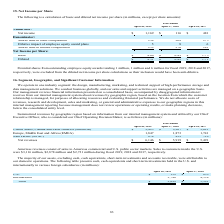According to Netapp's financial document, What was the sales to customers inside the U.S. in 2017? According to the financial document, $2,721 million. The relevant text states: "e the U.S. were $3,116 million, $2,878 million and $2,721 million during fiscal 2019, 2018 and 2017, respectively...." Also, Which years does the table provide information for Summarized revenues by geographic region? The document contains multiple relevant values: 2019, 2018, 2017. From the document: "April 26, 2019 April 27, 2018 April 28, 2017 April 26, 2019 April 27, 2018 April 28, 2017 April 26, 2019 April 27, 2018 April 28, 2017..." Also, Which industry segment does the company operate in? the design, manufacturing, marketing, and technical support of high-performance storage and data management solutions.. The document states: "We operate in one industry segment: the design, manufacturing, marketing, and technical support of high-performance storage and data management soluti..." Also, can you calculate: What was the change in the revenue from Asia Pacific between 2017 and 2018? Based on the calculation: 839-729, the result is 110 (in millions). This is based on the information: "Asia Pacific (APAC) 874 839 729 Asia Pacific (APAC) 874 839 729..." The key data points involved are: 729, 839. Also, How many years did revenue from the Americas exceed $3,000 million? Counting the relevant items in the document: 2019, 2018, 2017, I find 3 instances. The key data points involved are: 2017, 2018, 2019. Also, can you calculate: What was the percentage change in net revenues between 2018 and 2019? To answer this question, I need to perform calculations using the financial data. The calculation is: (6,146-5,919)/5,919, which equals 3.84 (percentage). This is based on the information: "Net revenues $ 6,146 $ 5,919 $ 5,491 Net revenues $ 6,146 $ 5,919 $ 5,491..." The key data points involved are: 5,919, 6,146. 